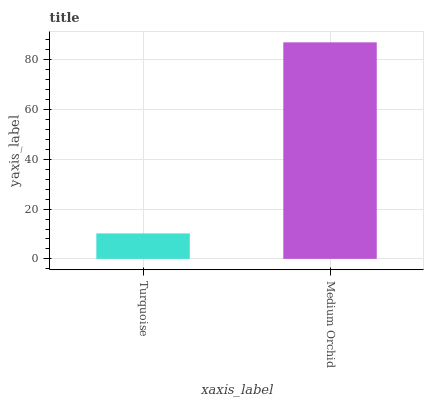Is Turquoise the minimum?
Answer yes or no. Yes. Is Medium Orchid the maximum?
Answer yes or no. Yes. Is Medium Orchid the minimum?
Answer yes or no. No. Is Medium Orchid greater than Turquoise?
Answer yes or no. Yes. Is Turquoise less than Medium Orchid?
Answer yes or no. Yes. Is Turquoise greater than Medium Orchid?
Answer yes or no. No. Is Medium Orchid less than Turquoise?
Answer yes or no. No. Is Medium Orchid the high median?
Answer yes or no. Yes. Is Turquoise the low median?
Answer yes or no. Yes. Is Turquoise the high median?
Answer yes or no. No. Is Medium Orchid the low median?
Answer yes or no. No. 